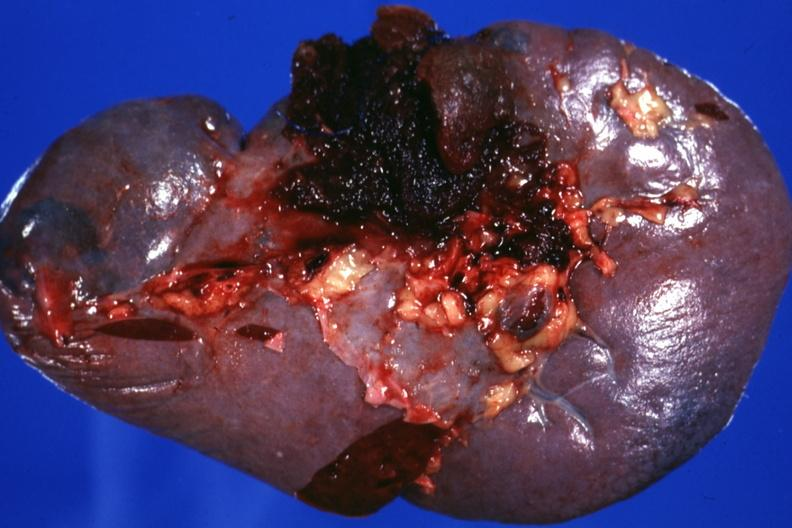where is this part in?
Answer the question using a single word or phrase. Spleen 